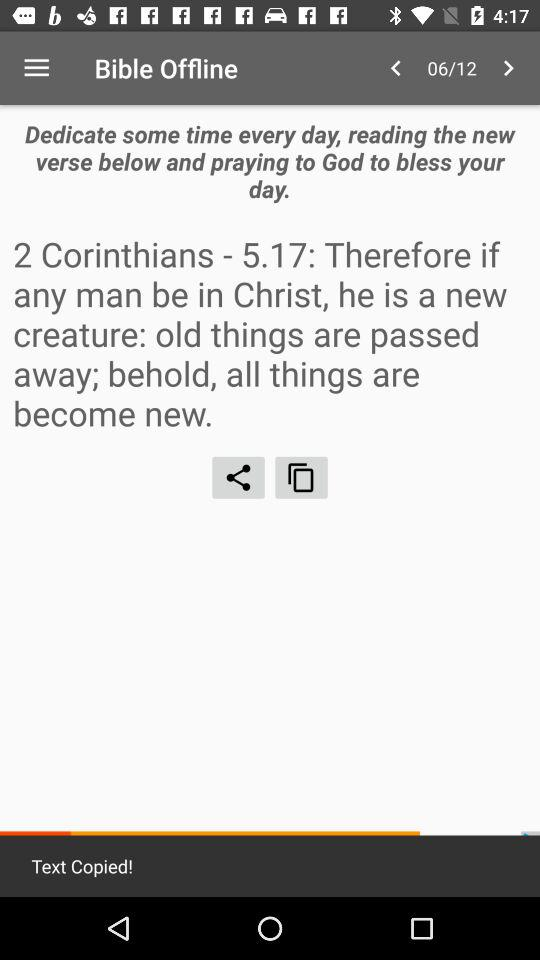How many pages in total are there? There are 12 pages. 